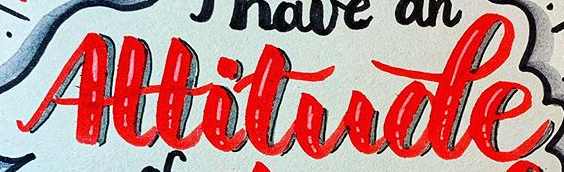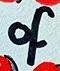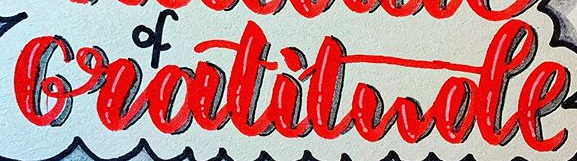Identify the words shown in these images in order, separated by a semicolon. Altitude; of; Gratitude 